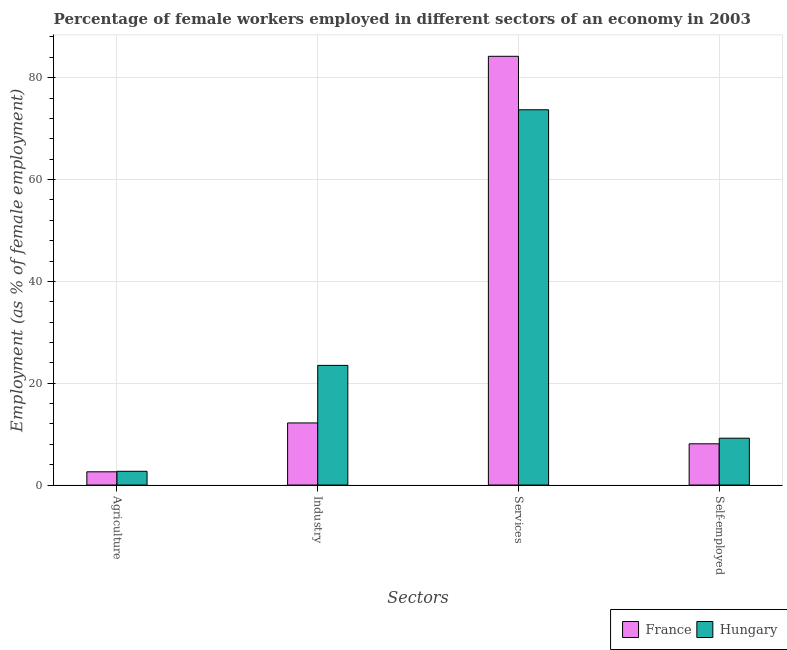How many different coloured bars are there?
Make the answer very short. 2. How many bars are there on the 1st tick from the right?
Your response must be concise. 2. What is the label of the 4th group of bars from the left?
Your response must be concise. Self-employed. What is the percentage of female workers in services in France?
Your answer should be compact. 84.2. Across all countries, what is the maximum percentage of female workers in agriculture?
Your answer should be compact. 2.7. Across all countries, what is the minimum percentage of female workers in agriculture?
Ensure brevity in your answer.  2.6. In which country was the percentage of female workers in industry maximum?
Provide a succinct answer. Hungary. What is the total percentage of female workers in agriculture in the graph?
Offer a terse response. 5.3. What is the difference between the percentage of female workers in agriculture in France and that in Hungary?
Your response must be concise. -0.1. What is the difference between the percentage of self employed female workers in Hungary and the percentage of female workers in industry in France?
Ensure brevity in your answer.  -3. What is the average percentage of female workers in industry per country?
Offer a very short reply. 17.85. What is the difference between the percentage of female workers in services and percentage of female workers in agriculture in Hungary?
Give a very brief answer. 71. In how many countries, is the percentage of self employed female workers greater than 48 %?
Your answer should be very brief. 0. What is the ratio of the percentage of self employed female workers in Hungary to that in France?
Your answer should be compact. 1.14. Is the percentage of female workers in services in Hungary less than that in France?
Your answer should be compact. Yes. What is the difference between the highest and the second highest percentage of female workers in services?
Offer a very short reply. 10.5. What is the difference between the highest and the lowest percentage of female workers in industry?
Make the answer very short. 11.3. Is it the case that in every country, the sum of the percentage of female workers in industry and percentage of female workers in agriculture is greater than the sum of percentage of female workers in services and percentage of self employed female workers?
Ensure brevity in your answer.  No. What does the 2nd bar from the left in Agriculture represents?
Your answer should be very brief. Hungary. What does the 2nd bar from the right in Self-employed represents?
Your answer should be very brief. France. Is it the case that in every country, the sum of the percentage of female workers in agriculture and percentage of female workers in industry is greater than the percentage of female workers in services?
Provide a succinct answer. No. How many countries are there in the graph?
Provide a short and direct response. 2. What is the difference between two consecutive major ticks on the Y-axis?
Provide a succinct answer. 20. Does the graph contain any zero values?
Your response must be concise. No. Does the graph contain grids?
Offer a very short reply. Yes. How many legend labels are there?
Offer a terse response. 2. What is the title of the graph?
Keep it short and to the point. Percentage of female workers employed in different sectors of an economy in 2003. Does "Vietnam" appear as one of the legend labels in the graph?
Make the answer very short. No. What is the label or title of the X-axis?
Make the answer very short. Sectors. What is the label or title of the Y-axis?
Offer a terse response. Employment (as % of female employment). What is the Employment (as % of female employment) of France in Agriculture?
Give a very brief answer. 2.6. What is the Employment (as % of female employment) of Hungary in Agriculture?
Provide a short and direct response. 2.7. What is the Employment (as % of female employment) in France in Industry?
Offer a very short reply. 12.2. What is the Employment (as % of female employment) in France in Services?
Offer a terse response. 84.2. What is the Employment (as % of female employment) in Hungary in Services?
Offer a terse response. 73.7. What is the Employment (as % of female employment) of France in Self-employed?
Provide a short and direct response. 8.1. What is the Employment (as % of female employment) in Hungary in Self-employed?
Offer a very short reply. 9.2. Across all Sectors, what is the maximum Employment (as % of female employment) in France?
Keep it short and to the point. 84.2. Across all Sectors, what is the maximum Employment (as % of female employment) in Hungary?
Offer a terse response. 73.7. Across all Sectors, what is the minimum Employment (as % of female employment) of France?
Offer a very short reply. 2.6. Across all Sectors, what is the minimum Employment (as % of female employment) in Hungary?
Your answer should be compact. 2.7. What is the total Employment (as % of female employment) of France in the graph?
Your answer should be very brief. 107.1. What is the total Employment (as % of female employment) in Hungary in the graph?
Provide a succinct answer. 109.1. What is the difference between the Employment (as % of female employment) in France in Agriculture and that in Industry?
Your answer should be very brief. -9.6. What is the difference between the Employment (as % of female employment) of Hungary in Agriculture and that in Industry?
Offer a terse response. -20.8. What is the difference between the Employment (as % of female employment) of France in Agriculture and that in Services?
Your answer should be compact. -81.6. What is the difference between the Employment (as % of female employment) of Hungary in Agriculture and that in Services?
Offer a very short reply. -71. What is the difference between the Employment (as % of female employment) of France in Agriculture and that in Self-employed?
Your answer should be compact. -5.5. What is the difference between the Employment (as % of female employment) of Hungary in Agriculture and that in Self-employed?
Make the answer very short. -6.5. What is the difference between the Employment (as % of female employment) of France in Industry and that in Services?
Your response must be concise. -72. What is the difference between the Employment (as % of female employment) of Hungary in Industry and that in Services?
Give a very brief answer. -50.2. What is the difference between the Employment (as % of female employment) in France in Industry and that in Self-employed?
Provide a short and direct response. 4.1. What is the difference between the Employment (as % of female employment) in France in Services and that in Self-employed?
Your answer should be very brief. 76.1. What is the difference between the Employment (as % of female employment) of Hungary in Services and that in Self-employed?
Offer a terse response. 64.5. What is the difference between the Employment (as % of female employment) of France in Agriculture and the Employment (as % of female employment) of Hungary in Industry?
Keep it short and to the point. -20.9. What is the difference between the Employment (as % of female employment) in France in Agriculture and the Employment (as % of female employment) in Hungary in Services?
Offer a very short reply. -71.1. What is the difference between the Employment (as % of female employment) in France in Agriculture and the Employment (as % of female employment) in Hungary in Self-employed?
Provide a short and direct response. -6.6. What is the difference between the Employment (as % of female employment) of France in Industry and the Employment (as % of female employment) of Hungary in Services?
Your response must be concise. -61.5. What is the difference between the Employment (as % of female employment) of France in Industry and the Employment (as % of female employment) of Hungary in Self-employed?
Your response must be concise. 3. What is the average Employment (as % of female employment) of France per Sectors?
Offer a terse response. 26.77. What is the average Employment (as % of female employment) of Hungary per Sectors?
Make the answer very short. 27.27. What is the difference between the Employment (as % of female employment) of France and Employment (as % of female employment) of Hungary in Agriculture?
Provide a short and direct response. -0.1. What is the difference between the Employment (as % of female employment) of France and Employment (as % of female employment) of Hungary in Industry?
Your response must be concise. -11.3. What is the ratio of the Employment (as % of female employment) in France in Agriculture to that in Industry?
Ensure brevity in your answer.  0.21. What is the ratio of the Employment (as % of female employment) in Hungary in Agriculture to that in Industry?
Give a very brief answer. 0.11. What is the ratio of the Employment (as % of female employment) in France in Agriculture to that in Services?
Keep it short and to the point. 0.03. What is the ratio of the Employment (as % of female employment) in Hungary in Agriculture to that in Services?
Provide a succinct answer. 0.04. What is the ratio of the Employment (as % of female employment) of France in Agriculture to that in Self-employed?
Provide a succinct answer. 0.32. What is the ratio of the Employment (as % of female employment) in Hungary in Agriculture to that in Self-employed?
Your answer should be very brief. 0.29. What is the ratio of the Employment (as % of female employment) in France in Industry to that in Services?
Give a very brief answer. 0.14. What is the ratio of the Employment (as % of female employment) in Hungary in Industry to that in Services?
Your answer should be compact. 0.32. What is the ratio of the Employment (as % of female employment) of France in Industry to that in Self-employed?
Offer a very short reply. 1.51. What is the ratio of the Employment (as % of female employment) of Hungary in Industry to that in Self-employed?
Provide a succinct answer. 2.55. What is the ratio of the Employment (as % of female employment) of France in Services to that in Self-employed?
Make the answer very short. 10.4. What is the ratio of the Employment (as % of female employment) in Hungary in Services to that in Self-employed?
Provide a succinct answer. 8.01. What is the difference between the highest and the second highest Employment (as % of female employment) in France?
Provide a short and direct response. 72. What is the difference between the highest and the second highest Employment (as % of female employment) of Hungary?
Provide a succinct answer. 50.2. What is the difference between the highest and the lowest Employment (as % of female employment) in France?
Keep it short and to the point. 81.6. 